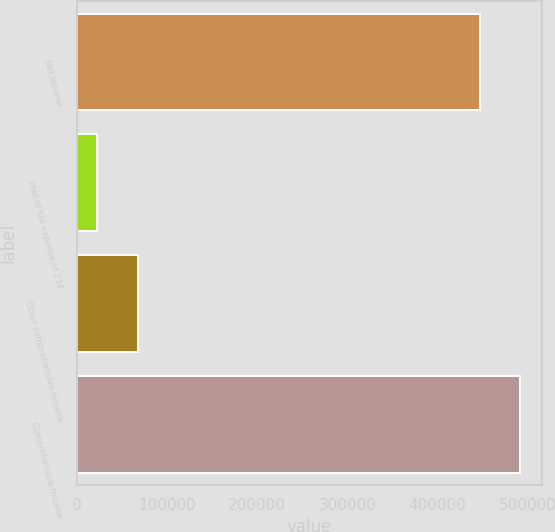Convert chart to OTSL. <chart><loc_0><loc_0><loc_500><loc_500><bar_chart><fcel>Net Income<fcel>(net of tax expense of 234<fcel>Other comprehensive income<fcel>Comprehensive Income<nl><fcel>446639<fcel>22811<fcel>67474.9<fcel>491303<nl></chart> 